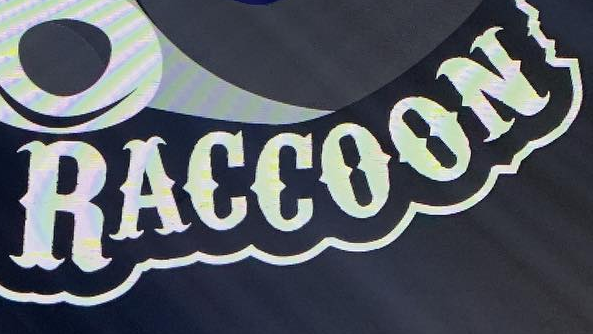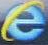What words can you see in these images in sequence, separated by a semicolon? RACCOON; e 